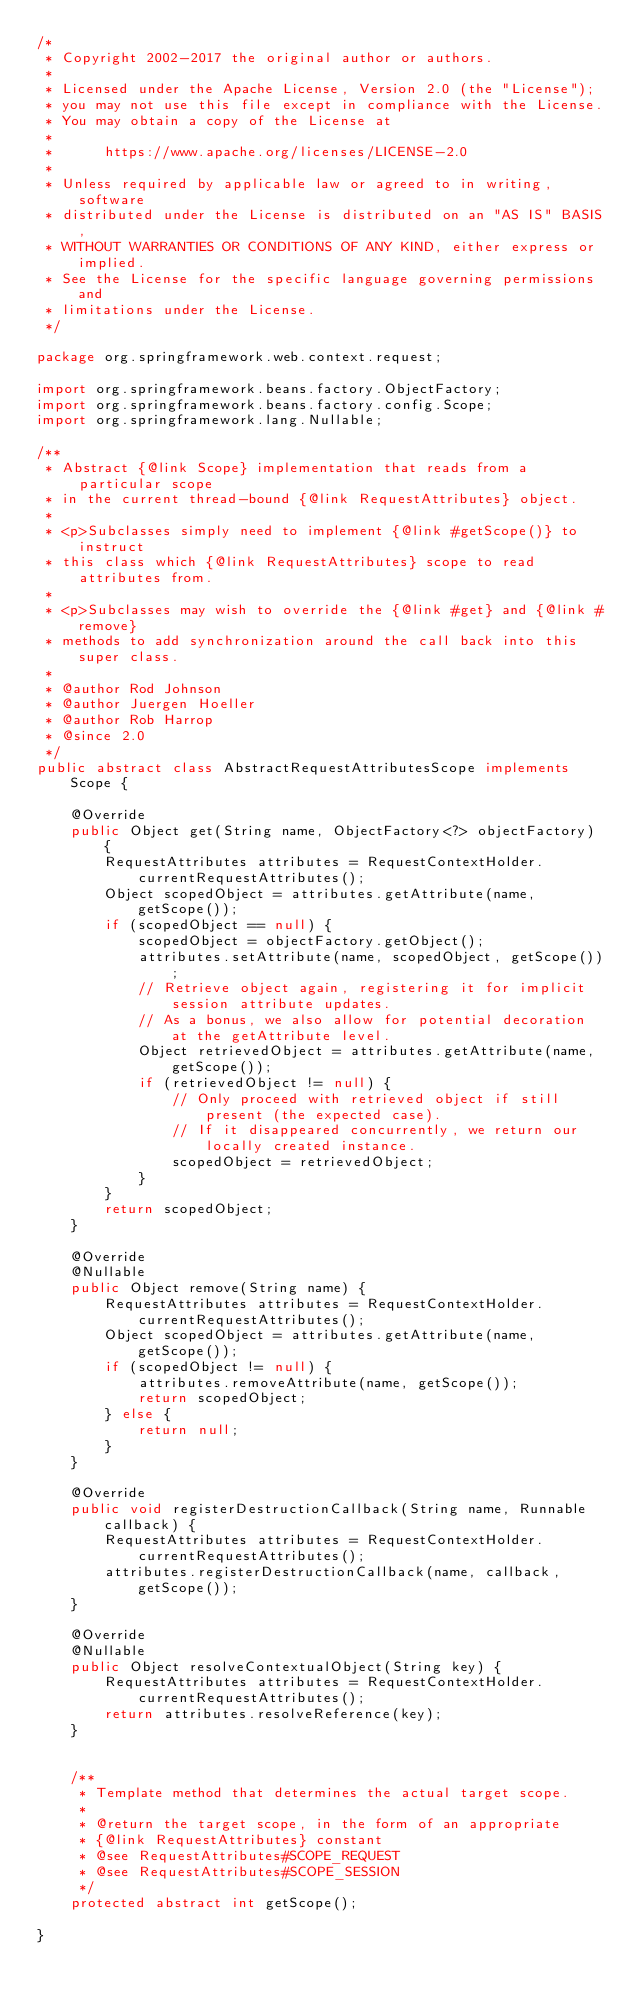Convert code to text. <code><loc_0><loc_0><loc_500><loc_500><_Java_>/*
 * Copyright 2002-2017 the original author or authors.
 *
 * Licensed under the Apache License, Version 2.0 (the "License");
 * you may not use this file except in compliance with the License.
 * You may obtain a copy of the License at
 *
 *      https://www.apache.org/licenses/LICENSE-2.0
 *
 * Unless required by applicable law or agreed to in writing, software
 * distributed under the License is distributed on an "AS IS" BASIS,
 * WITHOUT WARRANTIES OR CONDITIONS OF ANY KIND, either express or implied.
 * See the License for the specific language governing permissions and
 * limitations under the License.
 */

package org.springframework.web.context.request;

import org.springframework.beans.factory.ObjectFactory;
import org.springframework.beans.factory.config.Scope;
import org.springframework.lang.Nullable;

/**
 * Abstract {@link Scope} implementation that reads from a particular scope
 * in the current thread-bound {@link RequestAttributes} object.
 *
 * <p>Subclasses simply need to implement {@link #getScope()} to instruct
 * this class which {@link RequestAttributes} scope to read attributes from.
 *
 * <p>Subclasses may wish to override the {@link #get} and {@link #remove}
 * methods to add synchronization around the call back into this super class.
 *
 * @author Rod Johnson
 * @author Juergen Hoeller
 * @author Rob Harrop
 * @since 2.0
 */
public abstract class AbstractRequestAttributesScope implements Scope {

    @Override
    public Object get(String name, ObjectFactory<?> objectFactory) {
        RequestAttributes attributes = RequestContextHolder.currentRequestAttributes();
        Object scopedObject = attributes.getAttribute(name, getScope());
        if (scopedObject == null) {
            scopedObject = objectFactory.getObject();
            attributes.setAttribute(name, scopedObject, getScope());
            // Retrieve object again, registering it for implicit session attribute updates.
            // As a bonus, we also allow for potential decoration at the getAttribute level.
            Object retrievedObject = attributes.getAttribute(name, getScope());
            if (retrievedObject != null) {
                // Only proceed with retrieved object if still present (the expected case).
                // If it disappeared concurrently, we return our locally created instance.
                scopedObject = retrievedObject;
            }
        }
        return scopedObject;
    }

    @Override
    @Nullable
    public Object remove(String name) {
        RequestAttributes attributes = RequestContextHolder.currentRequestAttributes();
        Object scopedObject = attributes.getAttribute(name, getScope());
        if (scopedObject != null) {
            attributes.removeAttribute(name, getScope());
            return scopedObject;
        } else {
            return null;
        }
    }

    @Override
    public void registerDestructionCallback(String name, Runnable callback) {
        RequestAttributes attributes = RequestContextHolder.currentRequestAttributes();
        attributes.registerDestructionCallback(name, callback, getScope());
    }

    @Override
    @Nullable
    public Object resolveContextualObject(String key) {
        RequestAttributes attributes = RequestContextHolder.currentRequestAttributes();
        return attributes.resolveReference(key);
    }


    /**
     * Template method that determines the actual target scope.
     *
     * @return the target scope, in the form of an appropriate
     * {@link RequestAttributes} constant
     * @see RequestAttributes#SCOPE_REQUEST
     * @see RequestAttributes#SCOPE_SESSION
     */
    protected abstract int getScope();

}
</code> 